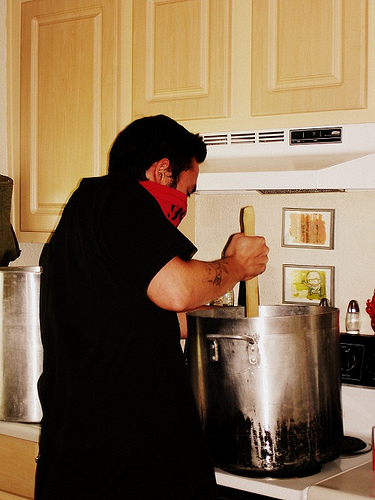<image>
Can you confirm if the man cooking is to the right of the big pot? No. The man cooking is not to the right of the big pot. The horizontal positioning shows a different relationship. 